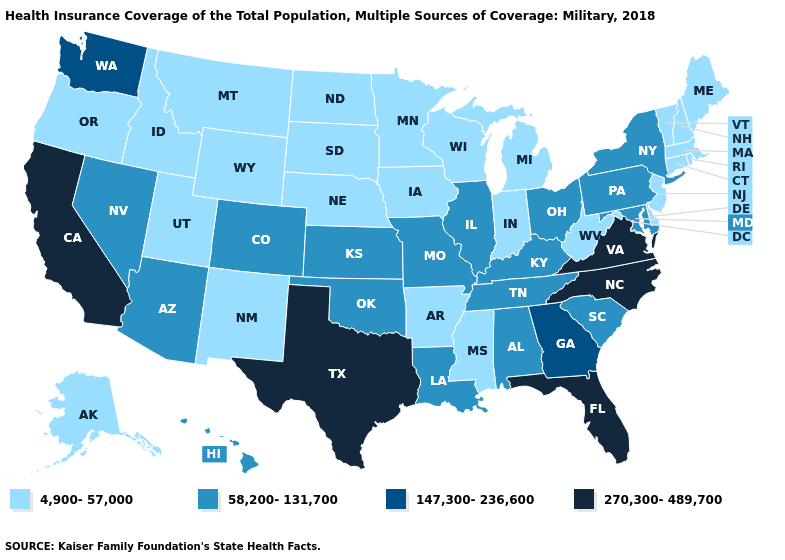Name the states that have a value in the range 4,900-57,000?
Quick response, please. Alaska, Arkansas, Connecticut, Delaware, Idaho, Indiana, Iowa, Maine, Massachusetts, Michigan, Minnesota, Mississippi, Montana, Nebraska, New Hampshire, New Jersey, New Mexico, North Dakota, Oregon, Rhode Island, South Dakota, Utah, Vermont, West Virginia, Wisconsin, Wyoming. Does Colorado have a higher value than Louisiana?
Quick response, please. No. Which states have the highest value in the USA?
Answer briefly. California, Florida, North Carolina, Texas, Virginia. What is the highest value in the South ?
Quick response, please. 270,300-489,700. Name the states that have a value in the range 58,200-131,700?
Concise answer only. Alabama, Arizona, Colorado, Hawaii, Illinois, Kansas, Kentucky, Louisiana, Maryland, Missouri, Nevada, New York, Ohio, Oklahoma, Pennsylvania, South Carolina, Tennessee. Among the states that border Connecticut , which have the lowest value?
Be succinct. Massachusetts, Rhode Island. Name the states that have a value in the range 147,300-236,600?
Concise answer only. Georgia, Washington. What is the lowest value in states that border Minnesota?
Short answer required. 4,900-57,000. Name the states that have a value in the range 58,200-131,700?
Write a very short answer. Alabama, Arizona, Colorado, Hawaii, Illinois, Kansas, Kentucky, Louisiana, Maryland, Missouri, Nevada, New York, Ohio, Oklahoma, Pennsylvania, South Carolina, Tennessee. What is the value of Kentucky?
Be succinct. 58,200-131,700. Does New York have the lowest value in the Northeast?
Write a very short answer. No. Which states have the lowest value in the USA?
Short answer required. Alaska, Arkansas, Connecticut, Delaware, Idaho, Indiana, Iowa, Maine, Massachusetts, Michigan, Minnesota, Mississippi, Montana, Nebraska, New Hampshire, New Jersey, New Mexico, North Dakota, Oregon, Rhode Island, South Dakota, Utah, Vermont, West Virginia, Wisconsin, Wyoming. How many symbols are there in the legend?
Quick response, please. 4. What is the highest value in the USA?
Give a very brief answer. 270,300-489,700. 